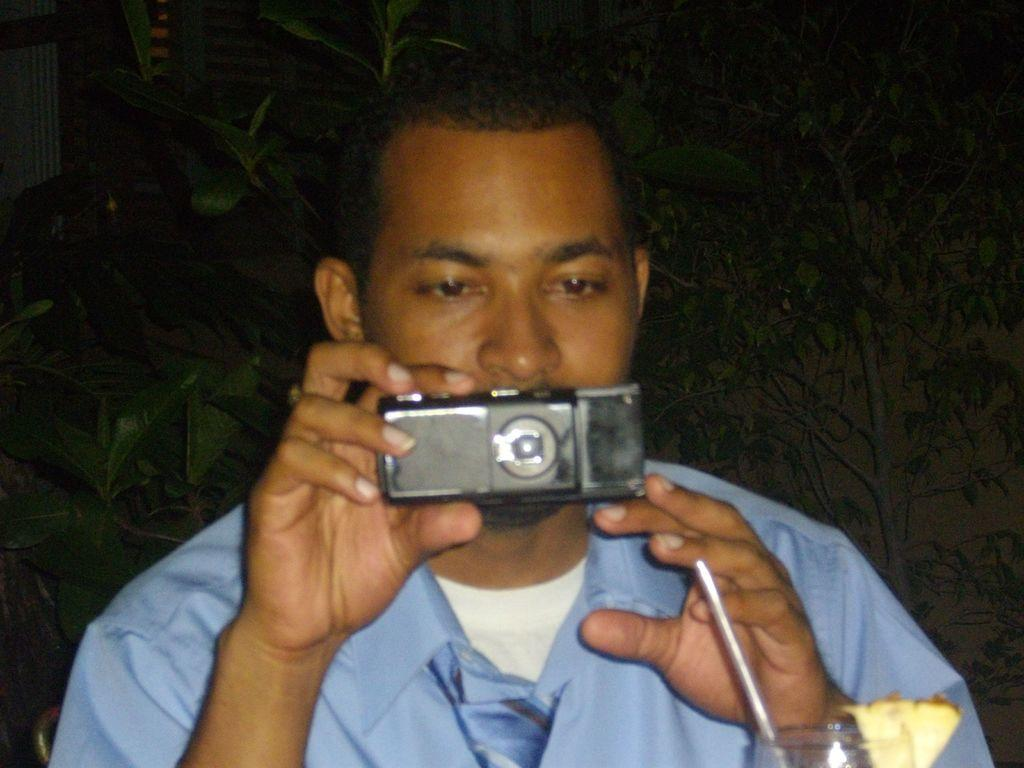Who is the main subject in the image? There is a man in the image. What is the man holding in his hand? The man is holding a camera in his hand. What is the man doing with the camera? The man is looking at the camera. What can be seen in the background of the image? There is a straw, a glass, and leaves in the background of the image. What language is the man speaking in the image? There is no indication of the man speaking in the image, so it cannot be determined what language he might be using. 